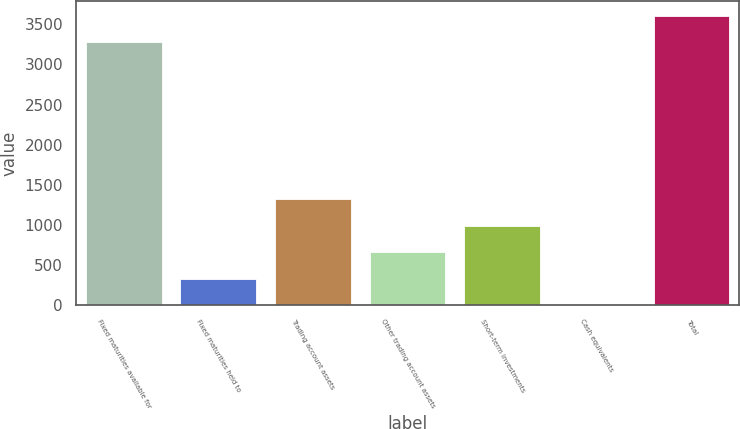<chart> <loc_0><loc_0><loc_500><loc_500><bar_chart><fcel>Fixed maturities available for<fcel>Fixed maturities held to<fcel>Trading account assets<fcel>Other trading account assets<fcel>Short-term investments<fcel>Cash equivalents<fcel>Total<nl><fcel>3280<fcel>330.32<fcel>1319.87<fcel>660.17<fcel>990.02<fcel>0.47<fcel>3609.85<nl></chart> 